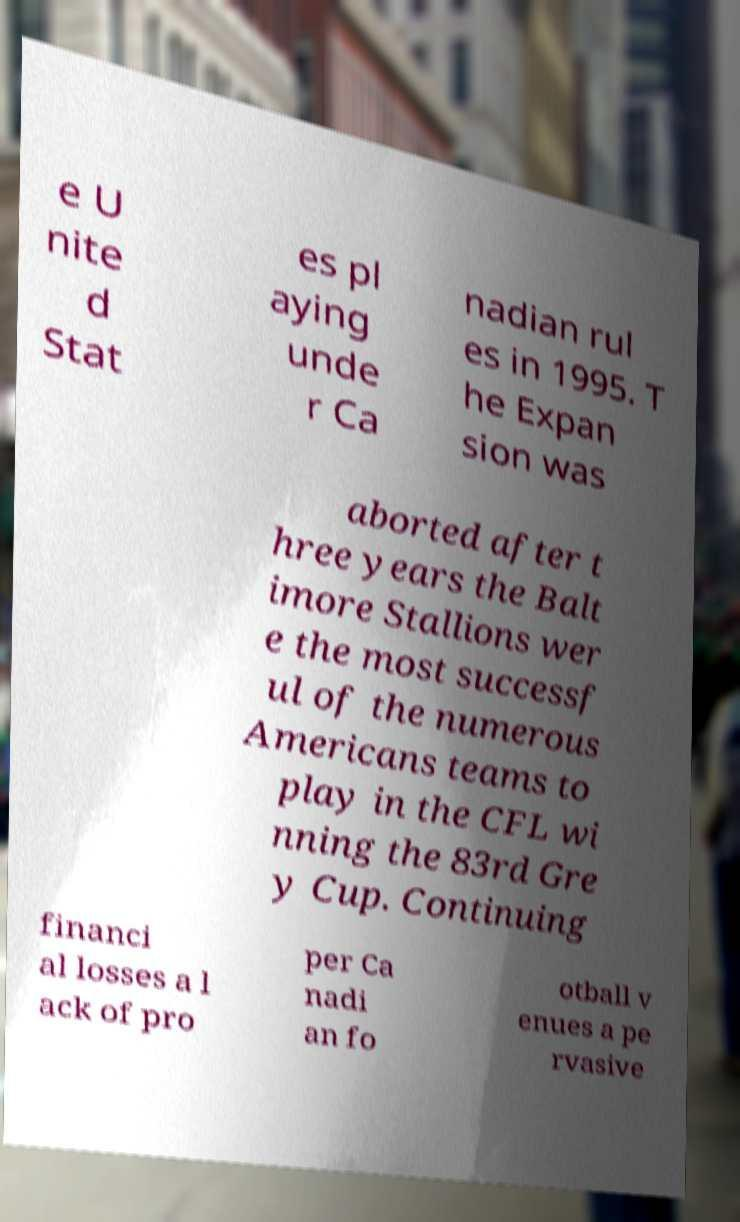Can you read and provide the text displayed in the image?This photo seems to have some interesting text. Can you extract and type it out for me? e U nite d Stat es pl aying unde r Ca nadian rul es in 1995. T he Expan sion was aborted after t hree years the Balt imore Stallions wer e the most successf ul of the numerous Americans teams to play in the CFL wi nning the 83rd Gre y Cup. Continuing financi al losses a l ack of pro per Ca nadi an fo otball v enues a pe rvasive 